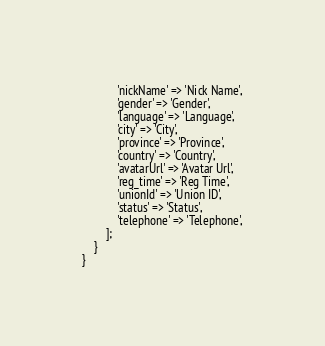<code> <loc_0><loc_0><loc_500><loc_500><_PHP_>            'nickName' => 'Nick Name',
            'gender' => 'Gender',
            'language' => 'Language',
            'city' => 'City',
            'province' => 'Province',
            'country' => 'Country',
            'avatarUrl' => 'Avatar Url',
            'reg_time' => 'Reg Time',
            'unionId' => 'Union ID',
            'status' => 'Status',
            'telephone' => 'Telephone',
        ];
    }
}
</code> 